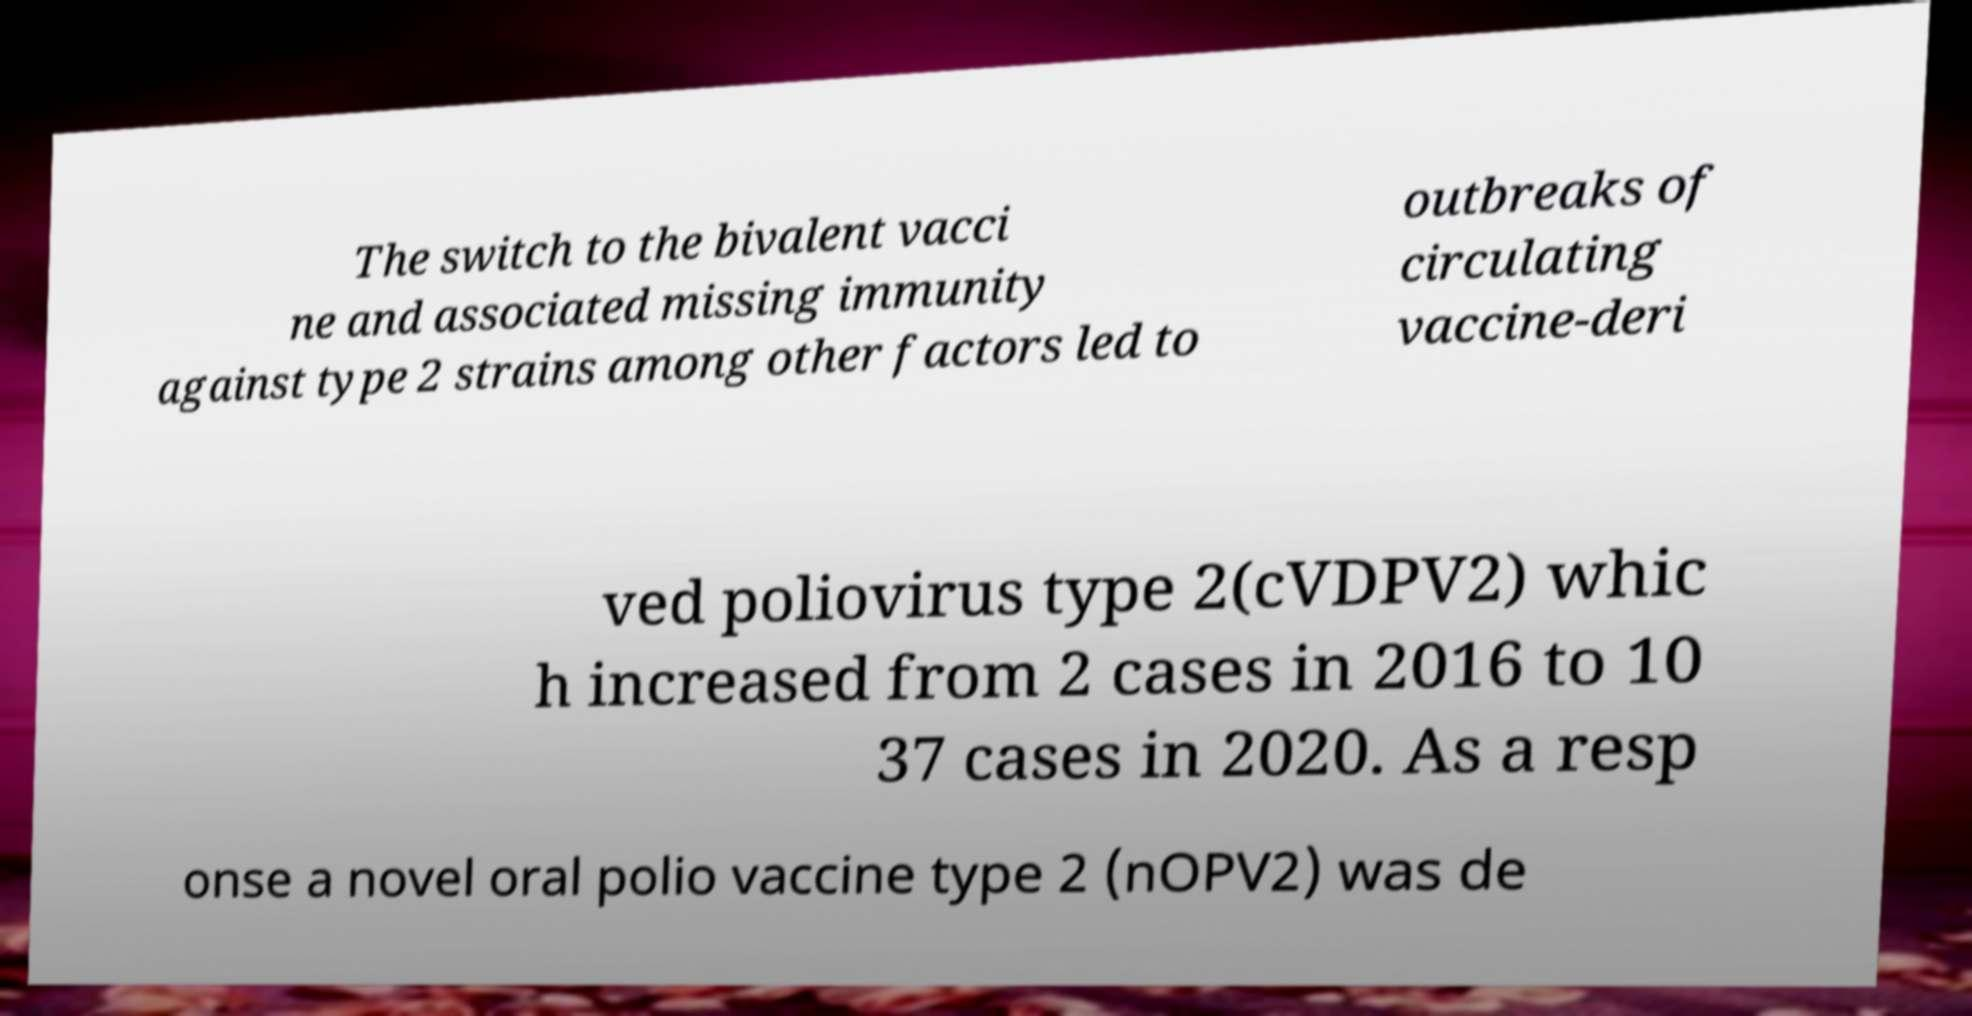Can you read and provide the text displayed in the image?This photo seems to have some interesting text. Can you extract and type it out for me? The switch to the bivalent vacci ne and associated missing immunity against type 2 strains among other factors led to outbreaks of circulating vaccine-deri ved poliovirus type 2(cVDPV2) whic h increased from 2 cases in 2016 to 10 37 cases in 2020. As a resp onse a novel oral polio vaccine type 2 (nOPV2) was de 